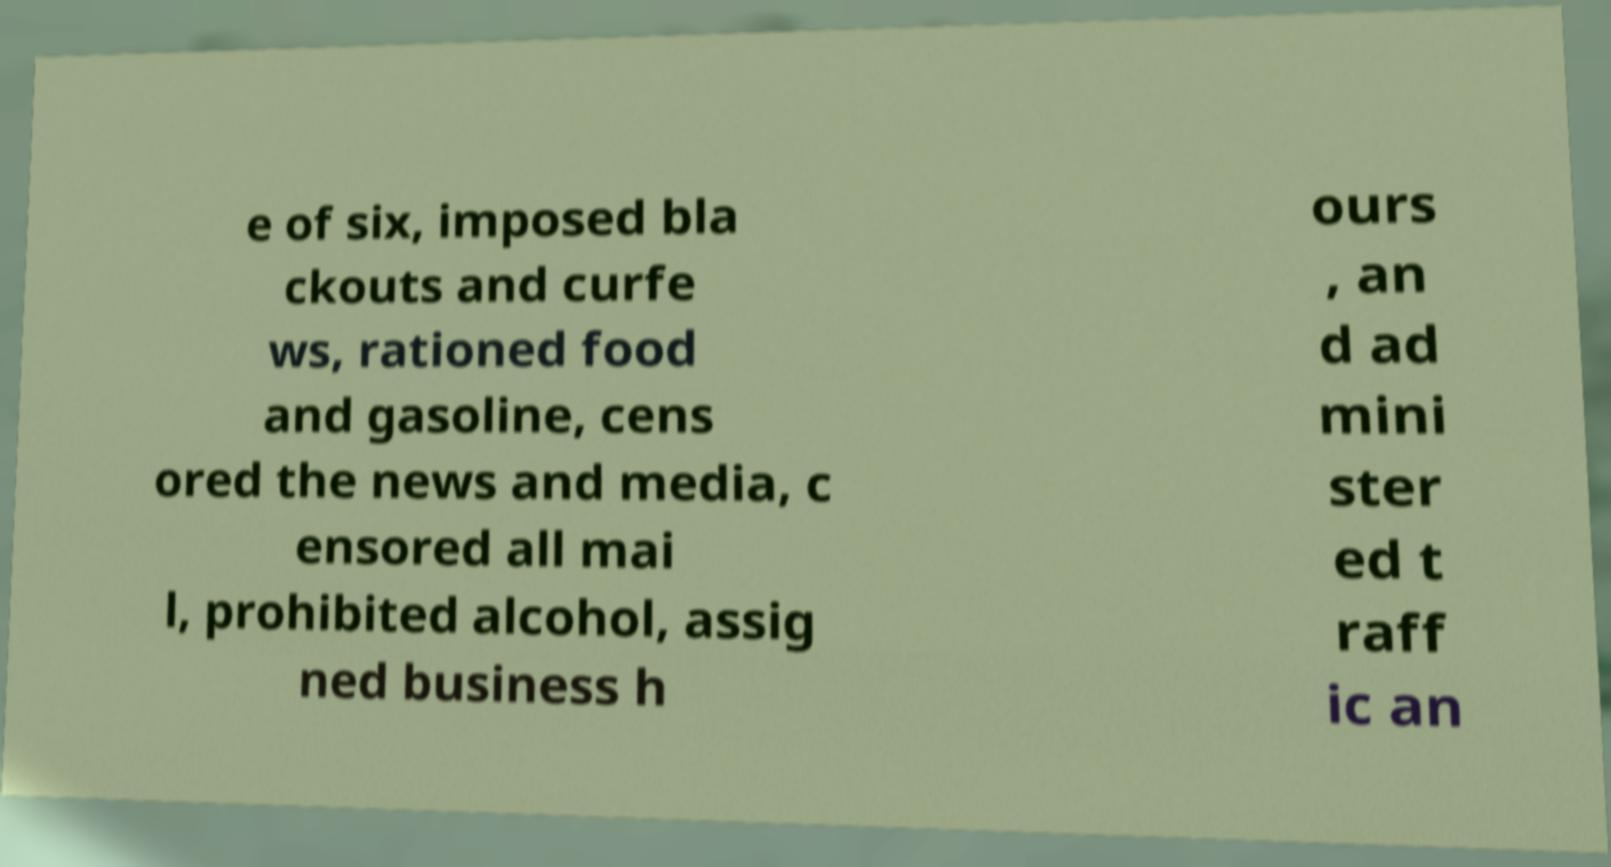What messages or text are displayed in this image? I need them in a readable, typed format. e of six, imposed bla ckouts and curfe ws, rationed food and gasoline, cens ored the news and media, c ensored all mai l, prohibited alcohol, assig ned business h ours , an d ad mini ster ed t raff ic an 